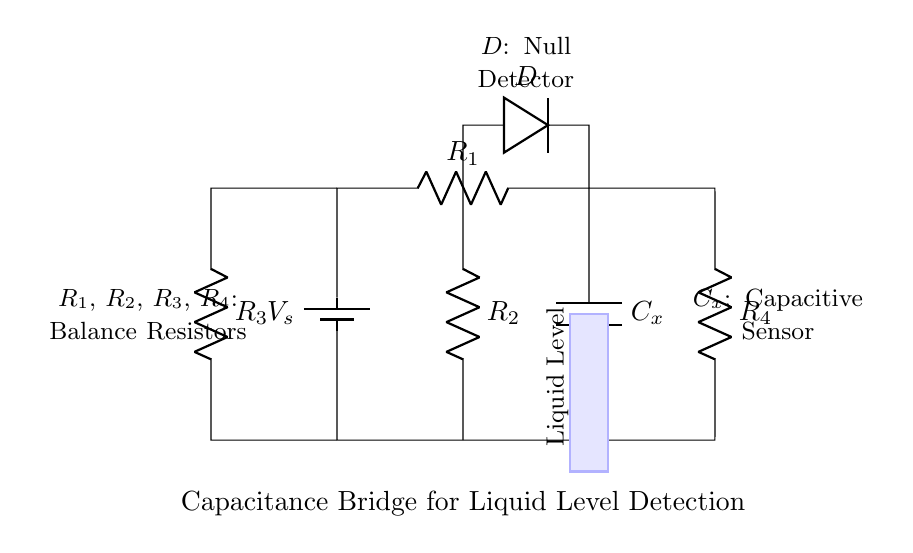What is the function of the component labeled D? The component labeled D is a null detector that identifies when the bridge is balanced, indicating that the capacitance is equal to the known value.
Answer: null detector What are the balance resistors in the circuit? The balance resistors are R1, R2, R3, and R4, which are used to balance the circuit and minimize the current through the detector D.
Answer: R1, R2, R3, R4 What effect does the liquid level have on Cx? The liquid level affects the capacitive sensor Cx by changing its capacitance based on the dielectric constant of the liquid, which is detected by the bridge circuit.
Answer: changes capacitance Which way does the current flow from the battery? The current flows from the positive terminal of the battery (Vs) through R1, Cx, and into the other components of the circuit.
Answer: positive to negative What does the blue rectangle represent? The blue rectangle represents the liquid level in the cooling system, which affects the capacitance of Cx as it changes.
Answer: liquid level When is the bridge considered balanced? The bridge is considered balanced when the output voltage at D is zero, indicating that the ratio of the capacitances and resistances are equal.
Answer: output voltage is zero How does varying R2 affect the circuit? Varying R2 changes the balance of the bridge circuit and may lead to different voltage readings at the null detector D, helping to achieve balance in detection.
Answer: changes detection balance 